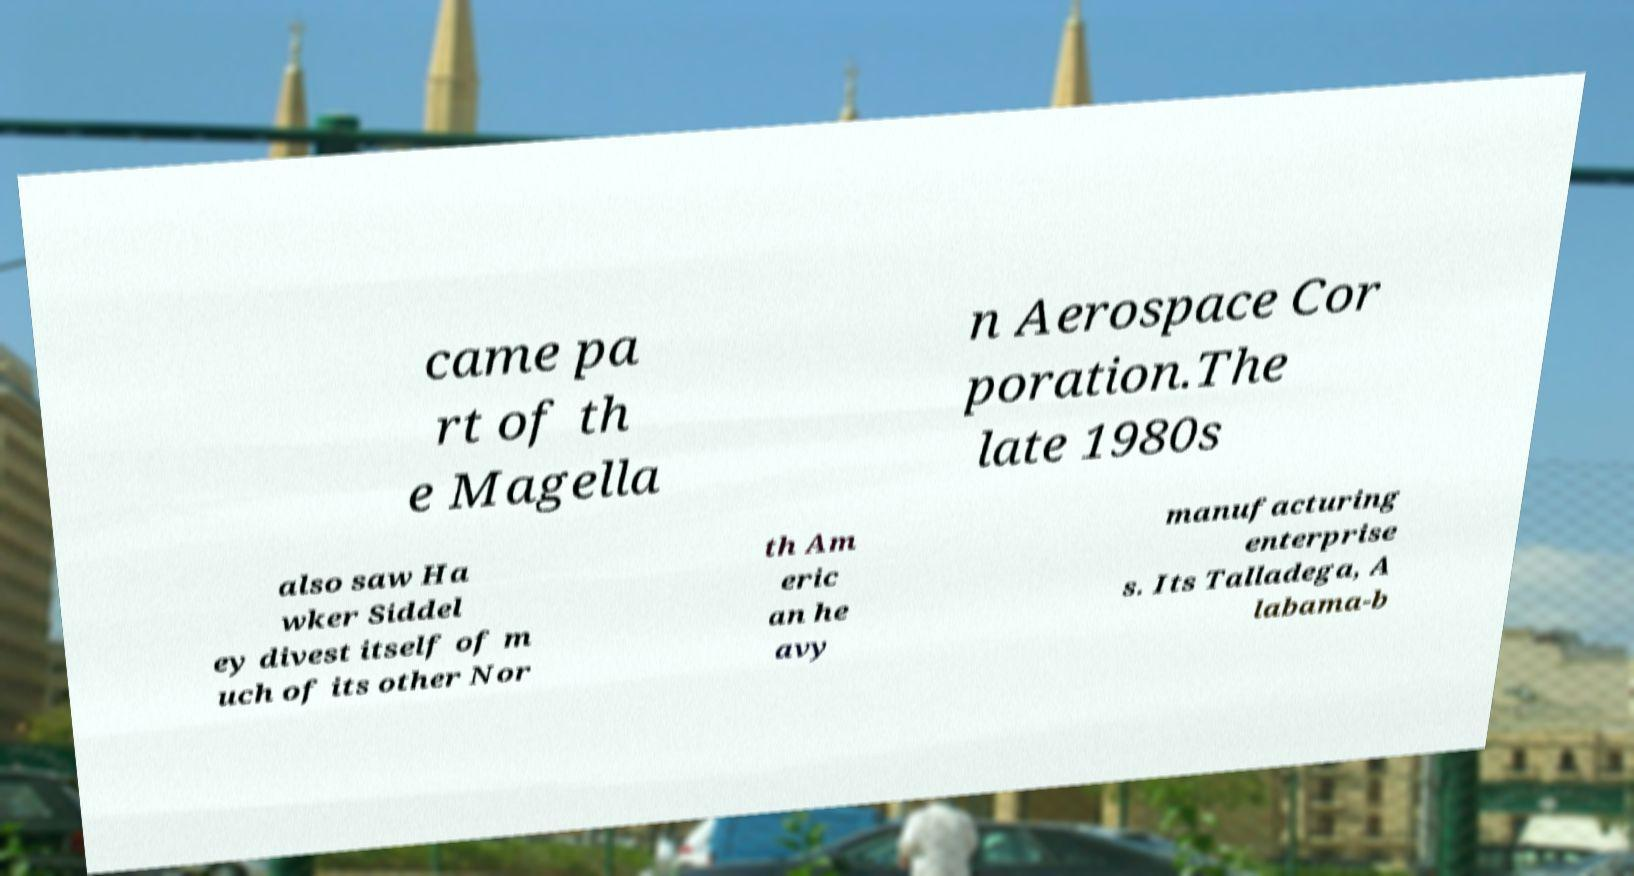Please read and relay the text visible in this image. What does it say? came pa rt of th e Magella n Aerospace Cor poration.The late 1980s also saw Ha wker Siddel ey divest itself of m uch of its other Nor th Am eric an he avy manufacturing enterprise s. Its Talladega, A labama-b 